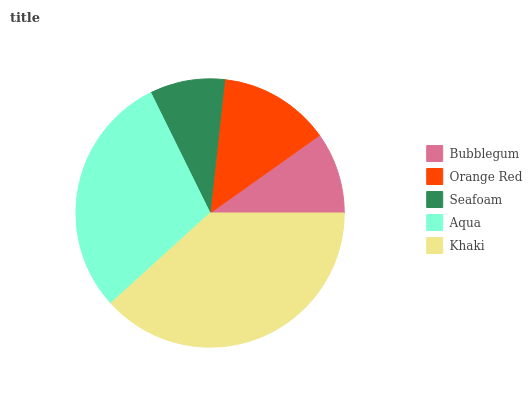Is Seafoam the minimum?
Answer yes or no. Yes. Is Khaki the maximum?
Answer yes or no. Yes. Is Orange Red the minimum?
Answer yes or no. No. Is Orange Red the maximum?
Answer yes or no. No. Is Orange Red greater than Bubblegum?
Answer yes or no. Yes. Is Bubblegum less than Orange Red?
Answer yes or no. Yes. Is Bubblegum greater than Orange Red?
Answer yes or no. No. Is Orange Red less than Bubblegum?
Answer yes or no. No. Is Orange Red the high median?
Answer yes or no. Yes. Is Orange Red the low median?
Answer yes or no. Yes. Is Aqua the high median?
Answer yes or no. No. Is Aqua the low median?
Answer yes or no. No. 